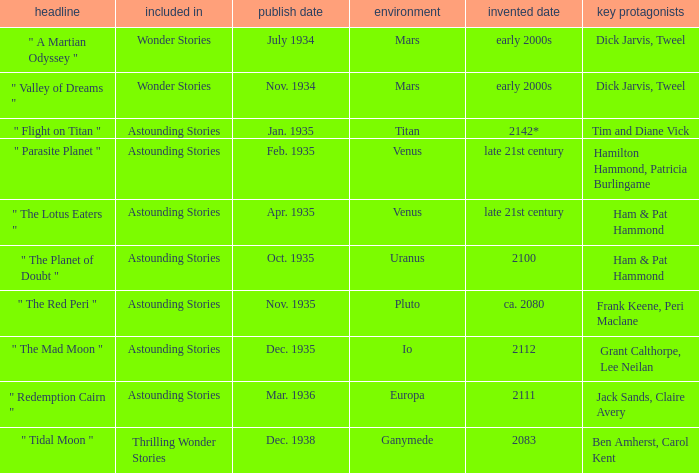What was the title of the piece published in july 1934 set on mars? Wonder Stories. 